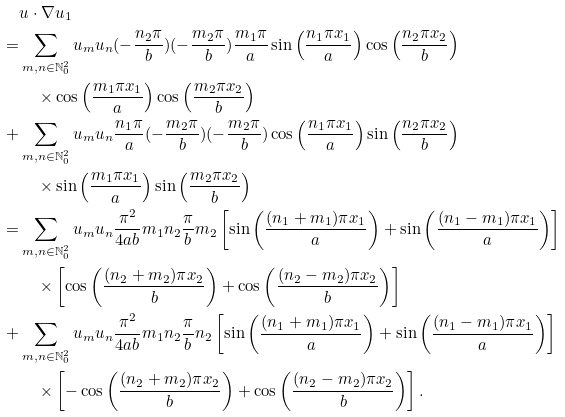Convert formula to latex. <formula><loc_0><loc_0><loc_500><loc_500>& u \cdot \nabla u _ { 1 } \\ = & \sum _ { m , n \in \mathbb { N } _ { 0 } ^ { 2 } } u _ { m } u _ { n } ( - \frac { n _ { 2 } \pi } { b } ) ( - \frac { m _ { 2 } \pi } { b } ) \frac { m _ { 1 } \pi } { a } \sin \left ( \frac { n _ { 1 } \pi x _ { 1 } } { a } \right ) \cos \left ( \frac { n _ { 2 } \pi x _ { 2 } } { b } \right ) \\ & \quad \times \cos \left ( \frac { m _ { 1 } \pi x _ { 1 } } { a } \right ) \cos \left ( \frac { m _ { 2 } \pi x _ { 2 } } { b } \right ) \\ + & \sum _ { m , n \in \mathbb { N } _ { 0 } ^ { 2 } } u _ { m } u _ { n } \frac { n _ { 1 } \pi } { a } ( - \frac { m _ { 2 } \pi } { b } ) ( - \frac { m _ { 2 } \pi } { b } ) \cos \left ( \frac { n _ { 1 } \pi x _ { 1 } } { a } \right ) \sin \left ( \frac { n _ { 2 } \pi x _ { 2 } } { b } \right ) \\ & \quad \times \sin \left ( \frac { m _ { 1 } \pi x _ { 1 } } { a } \right ) \sin \left ( \frac { m _ { 2 } \pi x _ { 2 } } { b } \right ) \\ = & \sum _ { m , n \in \mathbb { N } _ { 0 } ^ { 2 } } u _ { m } u _ { n } \frac { \pi ^ { 2 } } { 4 a b } m _ { 1 } n _ { 2 } \frac { \pi } { b } m _ { 2 } \left [ \sin \left ( \frac { ( n _ { 1 } + m _ { 1 } ) \pi x _ { 1 } } { a } \right ) + \sin \left ( \frac { ( n _ { 1 } - m _ { 1 } ) \pi x _ { 1 } } { a } \right ) \right ] \\ & \quad \times \left [ \cos \left ( \frac { ( n _ { 2 } + m _ { 2 } ) \pi x _ { 2 } } { b } \right ) + \cos \left ( \frac { ( n _ { 2 } - m _ { 2 } ) \pi x _ { 2 } } { b } \right ) \right ] \\ + & \sum _ { m , n \in \mathbb { N } _ { 0 } ^ { 2 } } u _ { m } u _ { n } \frac { \pi ^ { 2 } } { 4 a b } m _ { 1 } n _ { 2 } \frac { \pi } { b } n _ { 2 } \left [ \sin \left ( \frac { ( n _ { 1 } + m _ { 1 } ) \pi x _ { 1 } } { a } \right ) + \sin \left ( \frac { ( n _ { 1 } - m _ { 1 } ) \pi x _ { 1 } } { a } \right ) \right ] \\ & \quad \times \left [ - \cos \left ( \frac { ( n _ { 2 } + m _ { 2 } ) \pi x _ { 2 } } { b } \right ) + \cos \left ( \frac { ( n _ { 2 } - m _ { 2 } ) \pi x _ { 2 } } { b } \right ) \right ] .</formula> 